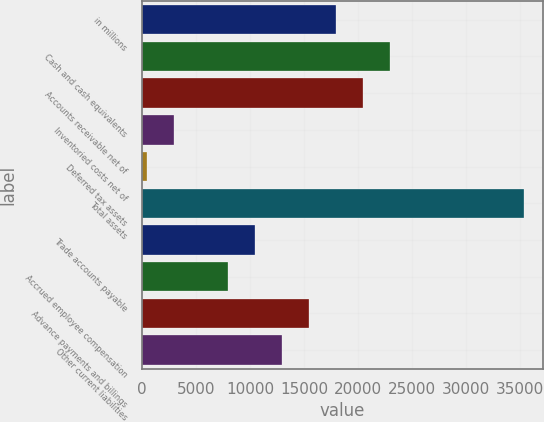<chart> <loc_0><loc_0><loc_500><loc_500><bar_chart><fcel>in millions<fcel>Cash and cash equivalents<fcel>Accounts receivable net of<fcel>Inventoried costs net of<fcel>Deferred tax assets<fcel>Total assets<fcel>Trade accounts payable<fcel>Accrued employee compensation<fcel>Advance payments and billings<fcel>Other current liabilities<nl><fcel>17936.5<fcel>22919.5<fcel>20428<fcel>2987.5<fcel>496<fcel>35377<fcel>10462<fcel>7970.5<fcel>15445<fcel>12953.5<nl></chart> 